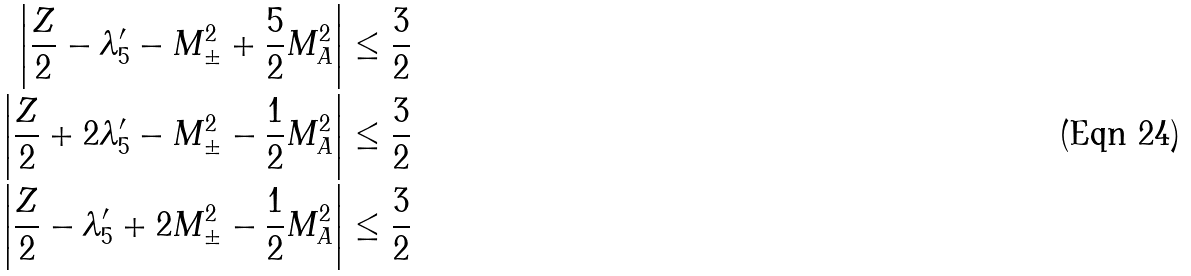Convert formula to latex. <formula><loc_0><loc_0><loc_500><loc_500>\left | \frac { Z } { 2 } - \lambda ^ { \prime } _ { 5 } - M ^ { 2 } _ { \pm } + \frac { 5 } { 2 } M ^ { 2 } _ { A } \right | & \leq \frac { 3 } { 2 } \\ \left | \frac { Z } { 2 } + 2 \lambda ^ { \prime } _ { 5 } - M ^ { 2 } _ { \pm } - \frac { 1 } { 2 } M ^ { 2 } _ { A } \right | & \leq \frac { 3 } { 2 } \\ \left | \frac { Z } { 2 } - \lambda ^ { \prime } _ { 5 } + 2 M ^ { 2 } _ { \pm } - \frac { 1 } { 2 } M ^ { 2 } _ { A } \right | & \leq \frac { 3 } { 2 } \\</formula> 